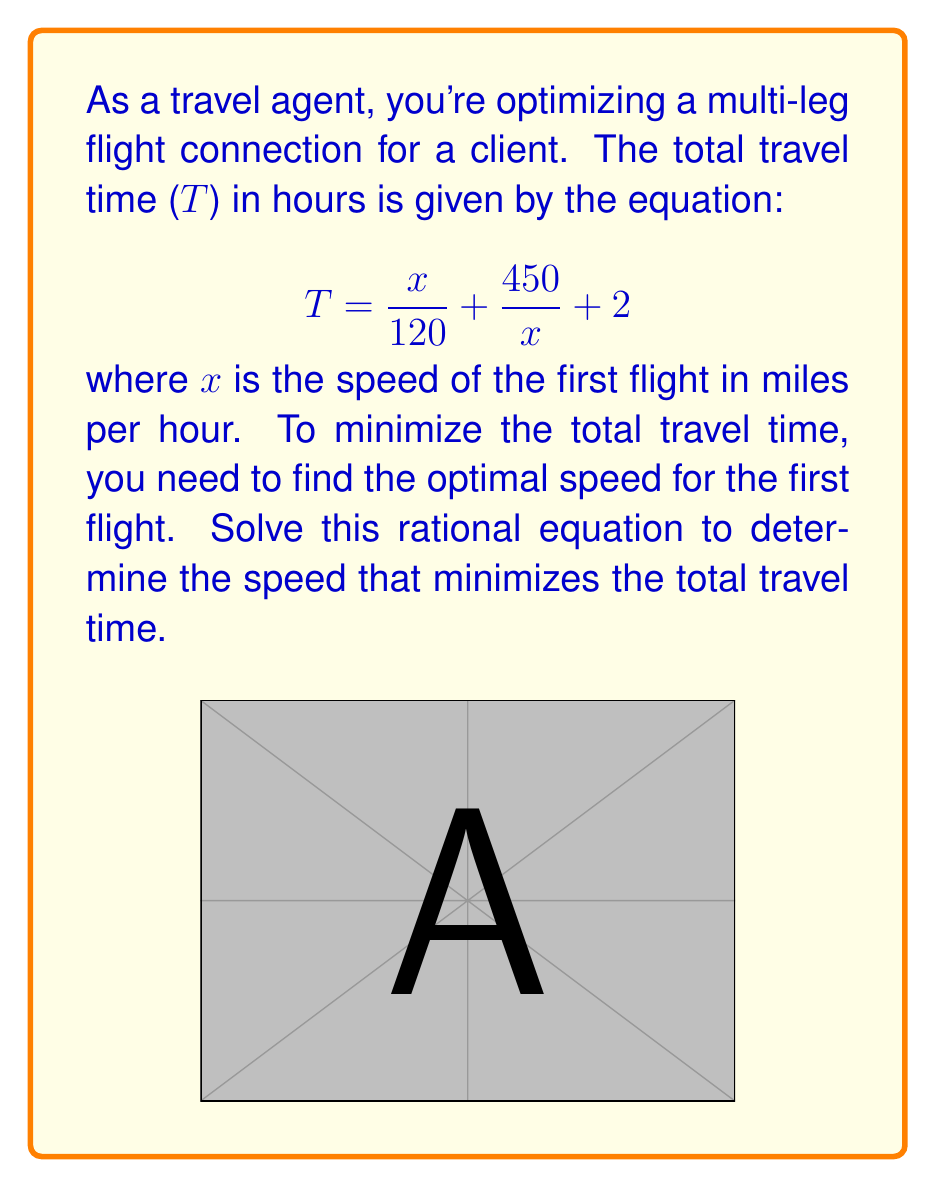Can you solve this math problem? To find the minimum value of T, we need to find the critical point where the derivative of T with respect to x equals zero. Here's how we solve it:

1) First, let's take the derivative of T with respect to x:
   $$\frac{dT}{dx} = \frac{1}{120} - \frac{450}{x^2}$$

2) Set this derivative equal to zero and solve for x:
   $$\frac{1}{120} - \frac{450}{x^2} = 0$$

3) Multiply both sides by $120x^2$:
   $$x^2 - 54000 = 0$$

4) Add 54000 to both sides:
   $$x^2 = 54000$$

5) Take the square root of both sides:
   $$x = \sqrt{54000} = 232.38$$

6) To confirm this is a minimum, we can check the second derivative:
   $$\frac{d^2T}{dx^2} = \frac{900}{x^3}$$
   This is always positive for positive x, confirming a minimum.

7) Therefore, the speed that minimizes the total travel time is approximately 232.38 mph.

8) We can calculate the minimum travel time by substituting this value back into the original equation:
   $$T_{min} = \frac{232.38}{120} + \frac{450}{232.38} + 2 \approx 5.87 \text{ hours}$$
Answer: 232.38 mph 